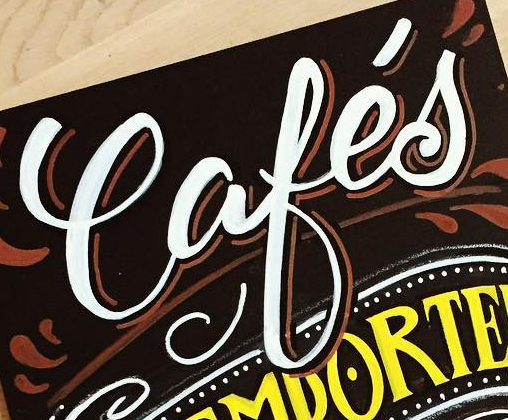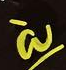Read the text from these images in sequence, separated by a semicolon. Cafés; à 